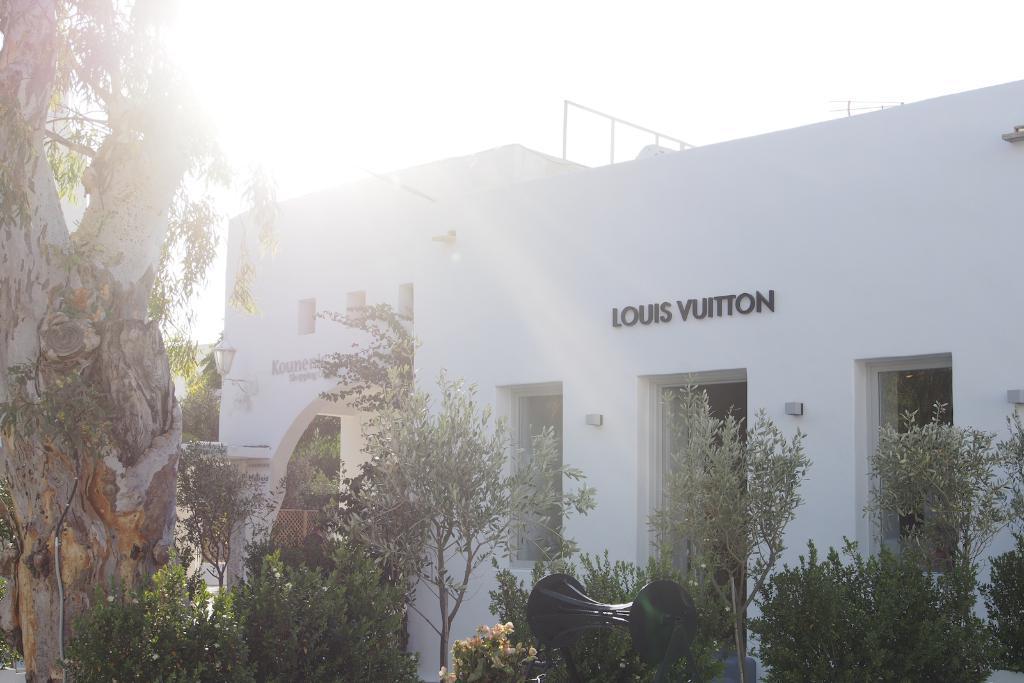Could you give a brief overview of what you see in this image? In this picture there is a building and there is text on the building and there are trees and there is an object and there is a light on the wall. At the top there is sky and there is a sunshine. 